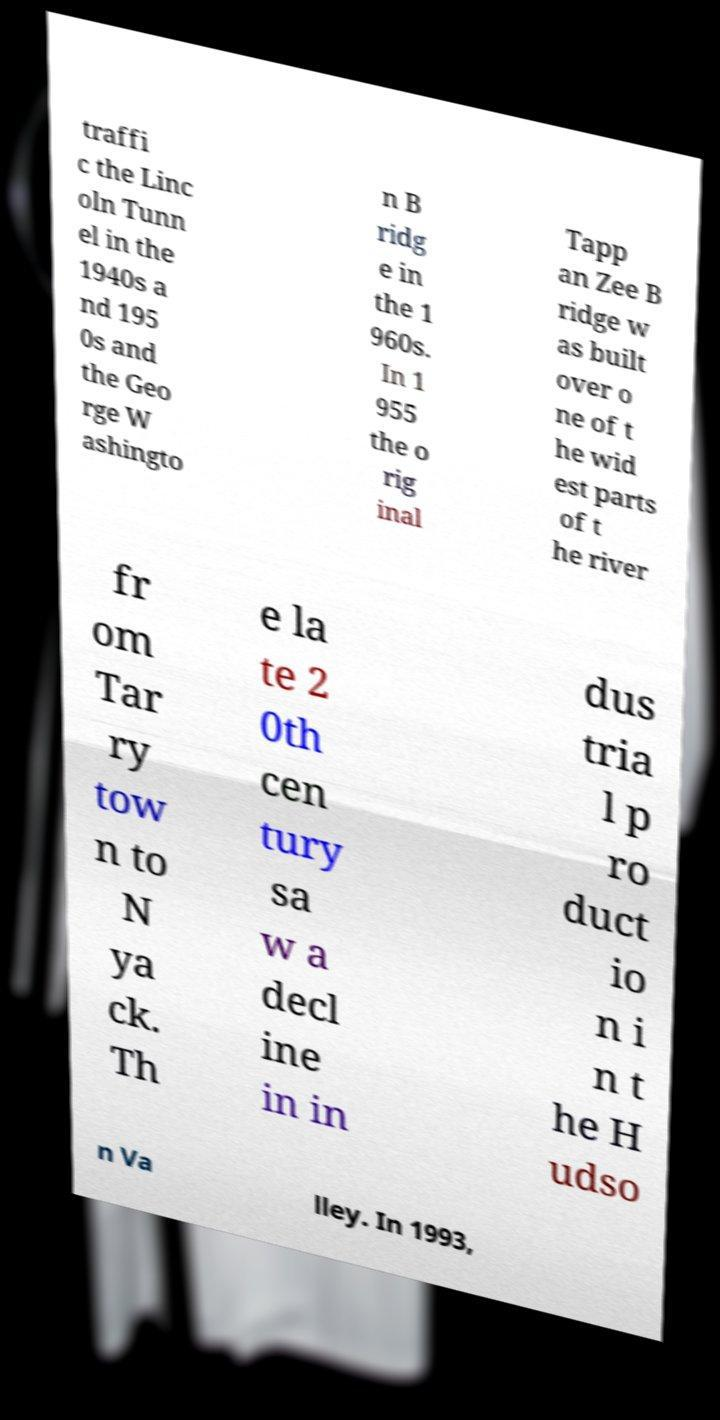Can you accurately transcribe the text from the provided image for me? traffi c the Linc oln Tunn el in the 1940s a nd 195 0s and the Geo rge W ashingto n B ridg e in the 1 960s. In 1 955 the o rig inal Tapp an Zee B ridge w as built over o ne of t he wid est parts of t he river fr om Tar ry tow n to N ya ck. Th e la te 2 0th cen tury sa w a decl ine in in dus tria l p ro duct io n i n t he H udso n Va lley. In 1993, 